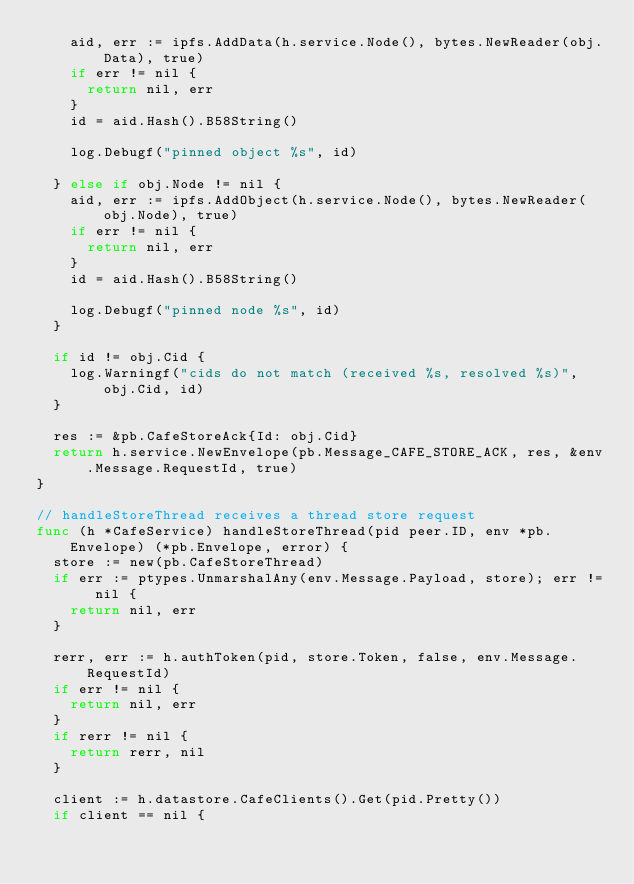<code> <loc_0><loc_0><loc_500><loc_500><_Go_>		aid, err := ipfs.AddData(h.service.Node(), bytes.NewReader(obj.Data), true)
		if err != nil {
			return nil, err
		}
		id = aid.Hash().B58String()

		log.Debugf("pinned object %s", id)

	} else if obj.Node != nil {
		aid, err := ipfs.AddObject(h.service.Node(), bytes.NewReader(obj.Node), true)
		if err != nil {
			return nil, err
		}
		id = aid.Hash().B58String()

		log.Debugf("pinned node %s", id)
	}

	if id != obj.Cid {
		log.Warningf("cids do not match (received %s, resolved %s)", obj.Cid, id)
	}

	res := &pb.CafeStoreAck{Id: obj.Cid}
	return h.service.NewEnvelope(pb.Message_CAFE_STORE_ACK, res, &env.Message.RequestId, true)
}

// handleStoreThread receives a thread store request
func (h *CafeService) handleStoreThread(pid peer.ID, env *pb.Envelope) (*pb.Envelope, error) {
	store := new(pb.CafeStoreThread)
	if err := ptypes.UnmarshalAny(env.Message.Payload, store); err != nil {
		return nil, err
	}

	rerr, err := h.authToken(pid, store.Token, false, env.Message.RequestId)
	if err != nil {
		return nil, err
	}
	if rerr != nil {
		return rerr, nil
	}

	client := h.datastore.CafeClients().Get(pid.Pretty())
	if client == nil {</code> 